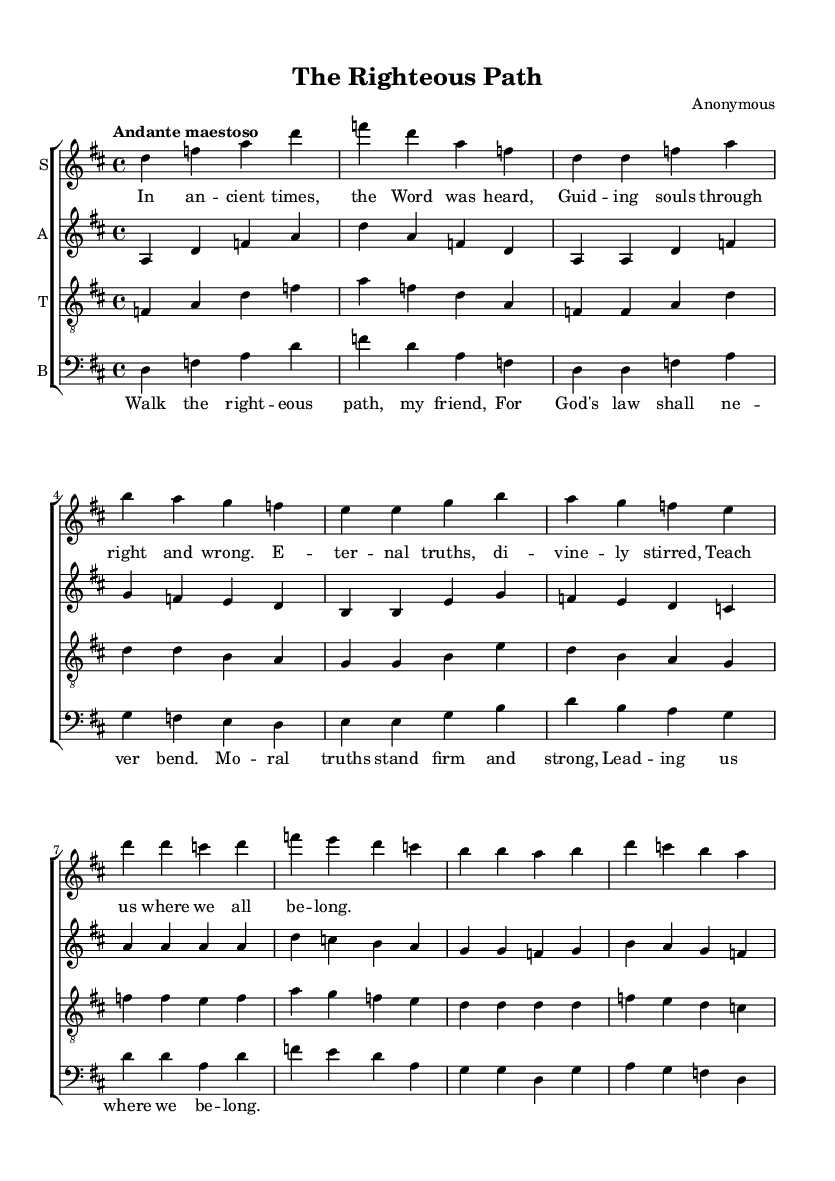What is the key signature of this music? The key signature is D major, which has two sharps (F# and C#). You can identify the key signature in the relevant part of the music sheet, typically located just after the clef sign at the beginning of the staff.
Answer: D major What is the time signature of this music? The time signature is 4/4, which indicates there are four beats in each measure and the quarter note receives one beat. This can be seen written at the beginning of the music within the staff system.
Answer: 4/4 What is the tempo marking in the score? The tempo marking is "Andante maestoso," which indicates a moderately slow pace, often associated with a dignified style. This is found in the upper part of the score, specifying how the music should be played.
Answer: Andante maestoso How many verses are in the lyrics? There is one verse present in the lyrics for the soprano part, as seen in the sheet music following the vocal lines. It consists of a series of lines that form a complete stanza.
Answer: One What instruments are included in the score? The score includes soprano, alto, tenor, and bass parts, which are all typical voices in a choir or choral setting. Each of these parts is outlined in separate staves in the score.
Answer: Soprano, alto, tenor, bass What moral teaching is reflected in the chorus? The chorus emphasizes the idea that moral truths are unchanging and guide individuals along a righteous path, which is a fundamental concept in many religious teachings. You can see this conveyed through the language used in the lyrics.
Answer: Moral truths stand firm and strong 